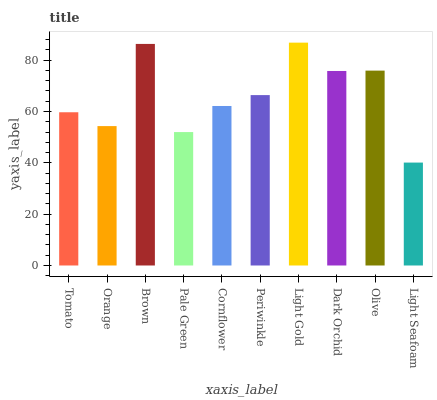Is Light Seafoam the minimum?
Answer yes or no. Yes. Is Light Gold the maximum?
Answer yes or no. Yes. Is Orange the minimum?
Answer yes or no. No. Is Orange the maximum?
Answer yes or no. No. Is Tomato greater than Orange?
Answer yes or no. Yes. Is Orange less than Tomato?
Answer yes or no. Yes. Is Orange greater than Tomato?
Answer yes or no. No. Is Tomato less than Orange?
Answer yes or no. No. Is Periwinkle the high median?
Answer yes or no. Yes. Is Cornflower the low median?
Answer yes or no. Yes. Is Brown the high median?
Answer yes or no. No. Is Pale Green the low median?
Answer yes or no. No. 